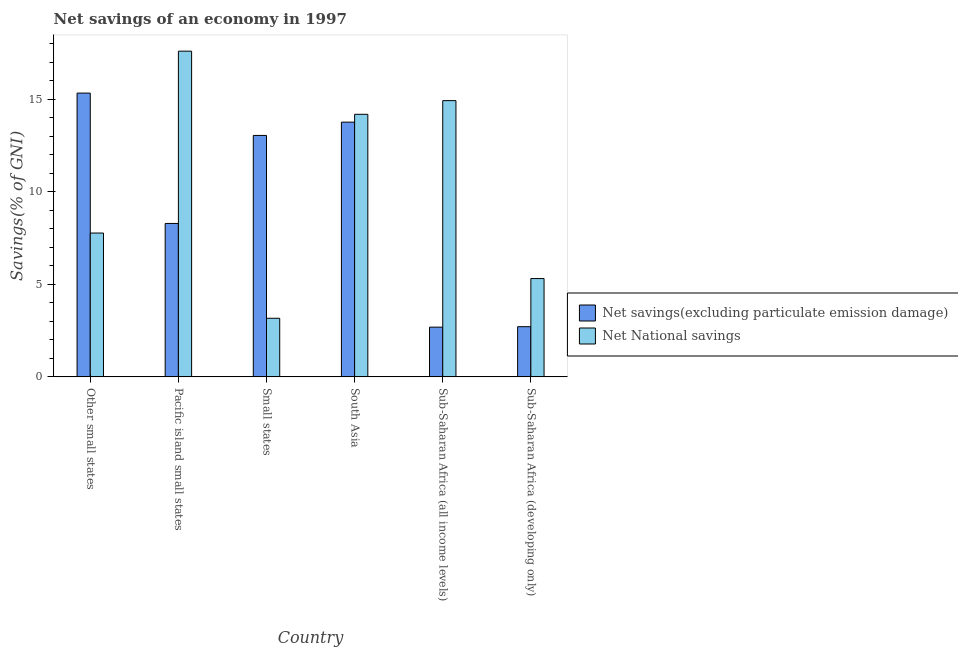How many different coloured bars are there?
Offer a very short reply. 2. How many groups of bars are there?
Provide a short and direct response. 6. Are the number of bars per tick equal to the number of legend labels?
Provide a short and direct response. Yes. How many bars are there on the 2nd tick from the right?
Make the answer very short. 2. What is the net national savings in Small states?
Provide a short and direct response. 3.17. Across all countries, what is the maximum net savings(excluding particulate emission damage)?
Make the answer very short. 15.33. Across all countries, what is the minimum net savings(excluding particulate emission damage)?
Your answer should be very brief. 2.69. In which country was the net savings(excluding particulate emission damage) maximum?
Provide a short and direct response. Other small states. In which country was the net national savings minimum?
Your response must be concise. Small states. What is the total net national savings in the graph?
Ensure brevity in your answer.  62.95. What is the difference between the net national savings in Small states and that in Sub-Saharan Africa (all income levels)?
Your response must be concise. -11.76. What is the difference between the net savings(excluding particulate emission damage) in Small states and the net national savings in Other small states?
Provide a succinct answer. 5.27. What is the average net national savings per country?
Ensure brevity in your answer.  10.49. What is the difference between the net national savings and net savings(excluding particulate emission damage) in Pacific island small states?
Your answer should be very brief. 9.31. In how many countries, is the net savings(excluding particulate emission damage) greater than 5 %?
Offer a terse response. 4. What is the ratio of the net savings(excluding particulate emission damage) in Small states to that in Sub-Saharan Africa (all income levels)?
Your response must be concise. 4.86. Is the difference between the net savings(excluding particulate emission damage) in Pacific island small states and Sub-Saharan Africa (developing only) greater than the difference between the net national savings in Pacific island small states and Sub-Saharan Africa (developing only)?
Give a very brief answer. No. What is the difference between the highest and the second highest net national savings?
Offer a very short reply. 2.67. What is the difference between the highest and the lowest net savings(excluding particulate emission damage)?
Provide a short and direct response. 12.64. In how many countries, is the net savings(excluding particulate emission damage) greater than the average net savings(excluding particulate emission damage) taken over all countries?
Offer a very short reply. 3. Is the sum of the net national savings in Other small states and Pacific island small states greater than the maximum net savings(excluding particulate emission damage) across all countries?
Provide a short and direct response. Yes. What does the 1st bar from the left in Pacific island small states represents?
Ensure brevity in your answer.  Net savings(excluding particulate emission damage). What does the 2nd bar from the right in Sub-Saharan Africa (all income levels) represents?
Your answer should be compact. Net savings(excluding particulate emission damage). Are all the bars in the graph horizontal?
Make the answer very short. No. How many countries are there in the graph?
Provide a succinct answer. 6. What is the difference between two consecutive major ticks on the Y-axis?
Keep it short and to the point. 5. Where does the legend appear in the graph?
Your response must be concise. Center right. How many legend labels are there?
Your answer should be very brief. 2. What is the title of the graph?
Ensure brevity in your answer.  Net savings of an economy in 1997. What is the label or title of the Y-axis?
Your answer should be compact. Savings(% of GNI). What is the Savings(% of GNI) in Net savings(excluding particulate emission damage) in Other small states?
Provide a short and direct response. 15.33. What is the Savings(% of GNI) of Net National savings in Other small states?
Offer a terse response. 7.77. What is the Savings(% of GNI) in Net savings(excluding particulate emission damage) in Pacific island small states?
Your response must be concise. 8.29. What is the Savings(% of GNI) of Net National savings in Pacific island small states?
Make the answer very short. 17.6. What is the Savings(% of GNI) in Net savings(excluding particulate emission damage) in Small states?
Provide a succinct answer. 13.04. What is the Savings(% of GNI) of Net National savings in Small states?
Your answer should be very brief. 3.17. What is the Savings(% of GNI) of Net savings(excluding particulate emission damage) in South Asia?
Ensure brevity in your answer.  13.76. What is the Savings(% of GNI) in Net National savings in South Asia?
Your response must be concise. 14.18. What is the Savings(% of GNI) in Net savings(excluding particulate emission damage) in Sub-Saharan Africa (all income levels)?
Your response must be concise. 2.69. What is the Savings(% of GNI) in Net National savings in Sub-Saharan Africa (all income levels)?
Your response must be concise. 14.92. What is the Savings(% of GNI) in Net savings(excluding particulate emission damage) in Sub-Saharan Africa (developing only)?
Your answer should be very brief. 2.71. What is the Savings(% of GNI) in Net National savings in Sub-Saharan Africa (developing only)?
Your answer should be compact. 5.31. Across all countries, what is the maximum Savings(% of GNI) of Net savings(excluding particulate emission damage)?
Your answer should be very brief. 15.33. Across all countries, what is the maximum Savings(% of GNI) in Net National savings?
Keep it short and to the point. 17.6. Across all countries, what is the minimum Savings(% of GNI) of Net savings(excluding particulate emission damage)?
Keep it short and to the point. 2.69. Across all countries, what is the minimum Savings(% of GNI) of Net National savings?
Provide a succinct answer. 3.17. What is the total Savings(% of GNI) in Net savings(excluding particulate emission damage) in the graph?
Your answer should be very brief. 55.82. What is the total Savings(% of GNI) of Net National savings in the graph?
Provide a short and direct response. 62.95. What is the difference between the Savings(% of GNI) of Net savings(excluding particulate emission damage) in Other small states and that in Pacific island small states?
Your response must be concise. 7.04. What is the difference between the Savings(% of GNI) of Net National savings in Other small states and that in Pacific island small states?
Provide a short and direct response. -9.83. What is the difference between the Savings(% of GNI) of Net savings(excluding particulate emission damage) in Other small states and that in Small states?
Offer a very short reply. 2.29. What is the difference between the Savings(% of GNI) of Net National savings in Other small states and that in Small states?
Give a very brief answer. 4.6. What is the difference between the Savings(% of GNI) in Net savings(excluding particulate emission damage) in Other small states and that in South Asia?
Provide a succinct answer. 1.57. What is the difference between the Savings(% of GNI) of Net National savings in Other small states and that in South Asia?
Make the answer very short. -6.41. What is the difference between the Savings(% of GNI) of Net savings(excluding particulate emission damage) in Other small states and that in Sub-Saharan Africa (all income levels)?
Provide a short and direct response. 12.64. What is the difference between the Savings(% of GNI) in Net National savings in Other small states and that in Sub-Saharan Africa (all income levels)?
Your answer should be very brief. -7.15. What is the difference between the Savings(% of GNI) of Net savings(excluding particulate emission damage) in Other small states and that in Sub-Saharan Africa (developing only)?
Provide a short and direct response. 12.62. What is the difference between the Savings(% of GNI) in Net National savings in Other small states and that in Sub-Saharan Africa (developing only)?
Provide a short and direct response. 2.46. What is the difference between the Savings(% of GNI) in Net savings(excluding particulate emission damage) in Pacific island small states and that in Small states?
Offer a terse response. -4.75. What is the difference between the Savings(% of GNI) in Net National savings in Pacific island small states and that in Small states?
Your response must be concise. 14.43. What is the difference between the Savings(% of GNI) in Net savings(excluding particulate emission damage) in Pacific island small states and that in South Asia?
Ensure brevity in your answer.  -5.47. What is the difference between the Savings(% of GNI) in Net National savings in Pacific island small states and that in South Asia?
Your answer should be very brief. 3.41. What is the difference between the Savings(% of GNI) in Net savings(excluding particulate emission damage) in Pacific island small states and that in Sub-Saharan Africa (all income levels)?
Make the answer very short. 5.6. What is the difference between the Savings(% of GNI) of Net National savings in Pacific island small states and that in Sub-Saharan Africa (all income levels)?
Make the answer very short. 2.67. What is the difference between the Savings(% of GNI) in Net savings(excluding particulate emission damage) in Pacific island small states and that in Sub-Saharan Africa (developing only)?
Your answer should be compact. 5.58. What is the difference between the Savings(% of GNI) in Net National savings in Pacific island small states and that in Sub-Saharan Africa (developing only)?
Provide a succinct answer. 12.28. What is the difference between the Savings(% of GNI) of Net savings(excluding particulate emission damage) in Small states and that in South Asia?
Give a very brief answer. -0.72. What is the difference between the Savings(% of GNI) in Net National savings in Small states and that in South Asia?
Your response must be concise. -11.02. What is the difference between the Savings(% of GNI) in Net savings(excluding particulate emission damage) in Small states and that in Sub-Saharan Africa (all income levels)?
Your answer should be compact. 10.36. What is the difference between the Savings(% of GNI) of Net National savings in Small states and that in Sub-Saharan Africa (all income levels)?
Your answer should be compact. -11.76. What is the difference between the Savings(% of GNI) in Net savings(excluding particulate emission damage) in Small states and that in Sub-Saharan Africa (developing only)?
Make the answer very short. 10.33. What is the difference between the Savings(% of GNI) in Net National savings in Small states and that in Sub-Saharan Africa (developing only)?
Ensure brevity in your answer.  -2.15. What is the difference between the Savings(% of GNI) in Net savings(excluding particulate emission damage) in South Asia and that in Sub-Saharan Africa (all income levels)?
Give a very brief answer. 11.07. What is the difference between the Savings(% of GNI) of Net National savings in South Asia and that in Sub-Saharan Africa (all income levels)?
Provide a short and direct response. -0.74. What is the difference between the Savings(% of GNI) of Net savings(excluding particulate emission damage) in South Asia and that in Sub-Saharan Africa (developing only)?
Keep it short and to the point. 11.05. What is the difference between the Savings(% of GNI) of Net National savings in South Asia and that in Sub-Saharan Africa (developing only)?
Offer a terse response. 8.87. What is the difference between the Savings(% of GNI) in Net savings(excluding particulate emission damage) in Sub-Saharan Africa (all income levels) and that in Sub-Saharan Africa (developing only)?
Keep it short and to the point. -0.02. What is the difference between the Savings(% of GNI) of Net National savings in Sub-Saharan Africa (all income levels) and that in Sub-Saharan Africa (developing only)?
Your answer should be very brief. 9.61. What is the difference between the Savings(% of GNI) of Net savings(excluding particulate emission damage) in Other small states and the Savings(% of GNI) of Net National savings in Pacific island small states?
Your answer should be compact. -2.27. What is the difference between the Savings(% of GNI) in Net savings(excluding particulate emission damage) in Other small states and the Savings(% of GNI) in Net National savings in Small states?
Give a very brief answer. 12.16. What is the difference between the Savings(% of GNI) of Net savings(excluding particulate emission damage) in Other small states and the Savings(% of GNI) of Net National savings in South Asia?
Your answer should be very brief. 1.15. What is the difference between the Savings(% of GNI) of Net savings(excluding particulate emission damage) in Other small states and the Savings(% of GNI) of Net National savings in Sub-Saharan Africa (all income levels)?
Offer a very short reply. 0.41. What is the difference between the Savings(% of GNI) in Net savings(excluding particulate emission damage) in Other small states and the Savings(% of GNI) in Net National savings in Sub-Saharan Africa (developing only)?
Keep it short and to the point. 10.02. What is the difference between the Savings(% of GNI) in Net savings(excluding particulate emission damage) in Pacific island small states and the Savings(% of GNI) in Net National savings in Small states?
Your response must be concise. 5.12. What is the difference between the Savings(% of GNI) in Net savings(excluding particulate emission damage) in Pacific island small states and the Savings(% of GNI) in Net National savings in South Asia?
Provide a succinct answer. -5.9. What is the difference between the Savings(% of GNI) of Net savings(excluding particulate emission damage) in Pacific island small states and the Savings(% of GNI) of Net National savings in Sub-Saharan Africa (all income levels)?
Provide a short and direct response. -6.63. What is the difference between the Savings(% of GNI) in Net savings(excluding particulate emission damage) in Pacific island small states and the Savings(% of GNI) in Net National savings in Sub-Saharan Africa (developing only)?
Your response must be concise. 2.98. What is the difference between the Savings(% of GNI) of Net savings(excluding particulate emission damage) in Small states and the Savings(% of GNI) of Net National savings in South Asia?
Your response must be concise. -1.14. What is the difference between the Savings(% of GNI) in Net savings(excluding particulate emission damage) in Small states and the Savings(% of GNI) in Net National savings in Sub-Saharan Africa (all income levels)?
Give a very brief answer. -1.88. What is the difference between the Savings(% of GNI) in Net savings(excluding particulate emission damage) in Small states and the Savings(% of GNI) in Net National savings in Sub-Saharan Africa (developing only)?
Ensure brevity in your answer.  7.73. What is the difference between the Savings(% of GNI) in Net savings(excluding particulate emission damage) in South Asia and the Savings(% of GNI) in Net National savings in Sub-Saharan Africa (all income levels)?
Provide a short and direct response. -1.16. What is the difference between the Savings(% of GNI) of Net savings(excluding particulate emission damage) in South Asia and the Savings(% of GNI) of Net National savings in Sub-Saharan Africa (developing only)?
Your answer should be very brief. 8.45. What is the difference between the Savings(% of GNI) in Net savings(excluding particulate emission damage) in Sub-Saharan Africa (all income levels) and the Savings(% of GNI) in Net National savings in Sub-Saharan Africa (developing only)?
Your answer should be compact. -2.62. What is the average Savings(% of GNI) of Net savings(excluding particulate emission damage) per country?
Your response must be concise. 9.3. What is the average Savings(% of GNI) of Net National savings per country?
Keep it short and to the point. 10.49. What is the difference between the Savings(% of GNI) in Net savings(excluding particulate emission damage) and Savings(% of GNI) in Net National savings in Other small states?
Provide a short and direct response. 7.56. What is the difference between the Savings(% of GNI) of Net savings(excluding particulate emission damage) and Savings(% of GNI) of Net National savings in Pacific island small states?
Offer a terse response. -9.31. What is the difference between the Savings(% of GNI) in Net savings(excluding particulate emission damage) and Savings(% of GNI) in Net National savings in Small states?
Provide a short and direct response. 9.88. What is the difference between the Savings(% of GNI) of Net savings(excluding particulate emission damage) and Savings(% of GNI) of Net National savings in South Asia?
Keep it short and to the point. -0.42. What is the difference between the Savings(% of GNI) in Net savings(excluding particulate emission damage) and Savings(% of GNI) in Net National savings in Sub-Saharan Africa (all income levels)?
Provide a succinct answer. -12.24. What is the difference between the Savings(% of GNI) in Net savings(excluding particulate emission damage) and Savings(% of GNI) in Net National savings in Sub-Saharan Africa (developing only)?
Ensure brevity in your answer.  -2.6. What is the ratio of the Savings(% of GNI) of Net savings(excluding particulate emission damage) in Other small states to that in Pacific island small states?
Keep it short and to the point. 1.85. What is the ratio of the Savings(% of GNI) in Net National savings in Other small states to that in Pacific island small states?
Your response must be concise. 0.44. What is the ratio of the Savings(% of GNI) of Net savings(excluding particulate emission damage) in Other small states to that in Small states?
Offer a terse response. 1.18. What is the ratio of the Savings(% of GNI) in Net National savings in Other small states to that in Small states?
Make the answer very short. 2.45. What is the ratio of the Savings(% of GNI) of Net savings(excluding particulate emission damage) in Other small states to that in South Asia?
Offer a very short reply. 1.11. What is the ratio of the Savings(% of GNI) in Net National savings in Other small states to that in South Asia?
Provide a succinct answer. 0.55. What is the ratio of the Savings(% of GNI) in Net savings(excluding particulate emission damage) in Other small states to that in Sub-Saharan Africa (all income levels)?
Your answer should be very brief. 5.71. What is the ratio of the Savings(% of GNI) of Net National savings in Other small states to that in Sub-Saharan Africa (all income levels)?
Provide a short and direct response. 0.52. What is the ratio of the Savings(% of GNI) in Net savings(excluding particulate emission damage) in Other small states to that in Sub-Saharan Africa (developing only)?
Your answer should be compact. 5.66. What is the ratio of the Savings(% of GNI) in Net National savings in Other small states to that in Sub-Saharan Africa (developing only)?
Make the answer very short. 1.46. What is the ratio of the Savings(% of GNI) of Net savings(excluding particulate emission damage) in Pacific island small states to that in Small states?
Give a very brief answer. 0.64. What is the ratio of the Savings(% of GNI) in Net National savings in Pacific island small states to that in Small states?
Offer a terse response. 5.56. What is the ratio of the Savings(% of GNI) of Net savings(excluding particulate emission damage) in Pacific island small states to that in South Asia?
Offer a very short reply. 0.6. What is the ratio of the Savings(% of GNI) of Net National savings in Pacific island small states to that in South Asia?
Provide a succinct answer. 1.24. What is the ratio of the Savings(% of GNI) in Net savings(excluding particulate emission damage) in Pacific island small states to that in Sub-Saharan Africa (all income levels)?
Offer a terse response. 3.09. What is the ratio of the Savings(% of GNI) in Net National savings in Pacific island small states to that in Sub-Saharan Africa (all income levels)?
Ensure brevity in your answer.  1.18. What is the ratio of the Savings(% of GNI) in Net savings(excluding particulate emission damage) in Pacific island small states to that in Sub-Saharan Africa (developing only)?
Ensure brevity in your answer.  3.06. What is the ratio of the Savings(% of GNI) of Net National savings in Pacific island small states to that in Sub-Saharan Africa (developing only)?
Your response must be concise. 3.31. What is the ratio of the Savings(% of GNI) in Net savings(excluding particulate emission damage) in Small states to that in South Asia?
Provide a short and direct response. 0.95. What is the ratio of the Savings(% of GNI) in Net National savings in Small states to that in South Asia?
Offer a very short reply. 0.22. What is the ratio of the Savings(% of GNI) of Net savings(excluding particulate emission damage) in Small states to that in Sub-Saharan Africa (all income levels)?
Keep it short and to the point. 4.86. What is the ratio of the Savings(% of GNI) in Net National savings in Small states to that in Sub-Saharan Africa (all income levels)?
Offer a terse response. 0.21. What is the ratio of the Savings(% of GNI) in Net savings(excluding particulate emission damage) in Small states to that in Sub-Saharan Africa (developing only)?
Offer a very short reply. 4.81. What is the ratio of the Savings(% of GNI) of Net National savings in Small states to that in Sub-Saharan Africa (developing only)?
Make the answer very short. 0.6. What is the ratio of the Savings(% of GNI) in Net savings(excluding particulate emission damage) in South Asia to that in Sub-Saharan Africa (all income levels)?
Provide a succinct answer. 5.12. What is the ratio of the Savings(% of GNI) of Net National savings in South Asia to that in Sub-Saharan Africa (all income levels)?
Your answer should be compact. 0.95. What is the ratio of the Savings(% of GNI) in Net savings(excluding particulate emission damage) in South Asia to that in Sub-Saharan Africa (developing only)?
Keep it short and to the point. 5.08. What is the ratio of the Savings(% of GNI) of Net National savings in South Asia to that in Sub-Saharan Africa (developing only)?
Provide a succinct answer. 2.67. What is the ratio of the Savings(% of GNI) in Net National savings in Sub-Saharan Africa (all income levels) to that in Sub-Saharan Africa (developing only)?
Offer a very short reply. 2.81. What is the difference between the highest and the second highest Savings(% of GNI) in Net savings(excluding particulate emission damage)?
Give a very brief answer. 1.57. What is the difference between the highest and the second highest Savings(% of GNI) in Net National savings?
Provide a short and direct response. 2.67. What is the difference between the highest and the lowest Savings(% of GNI) of Net savings(excluding particulate emission damage)?
Give a very brief answer. 12.64. What is the difference between the highest and the lowest Savings(% of GNI) of Net National savings?
Provide a short and direct response. 14.43. 